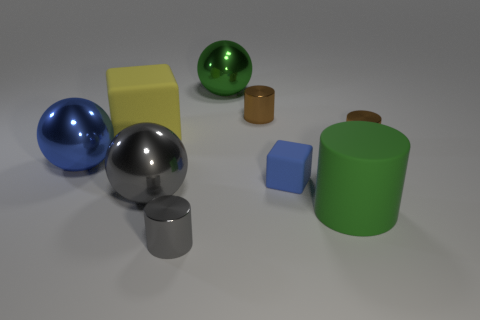Subtract all green balls. How many brown cylinders are left? 2 Subtract 1 balls. How many balls are left? 2 Subtract all small cylinders. How many cylinders are left? 1 Subtract all green cylinders. How many cylinders are left? 3 Subtract all balls. How many objects are left? 6 Subtract all purple cylinders. Subtract all gray balls. How many cylinders are left? 4 Subtract 0 red cubes. How many objects are left? 9 Subtract all large brown matte blocks. Subtract all small shiny cylinders. How many objects are left? 6 Add 7 small gray cylinders. How many small gray cylinders are left? 8 Add 8 small brown metal objects. How many small brown metal objects exist? 10 